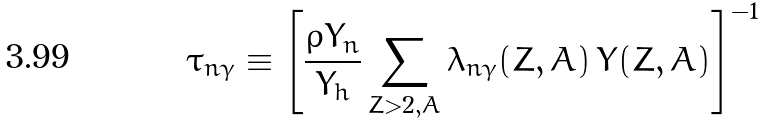<formula> <loc_0><loc_0><loc_500><loc_500>\tau _ { n \gamma } \equiv \left [ \frac { \rho Y _ { n } } { Y _ { h } } \sum _ { Z > 2 , A } \lambda _ { n \gamma } ( Z , A ) \, Y ( Z , A ) \right ] ^ { - 1 }</formula> 